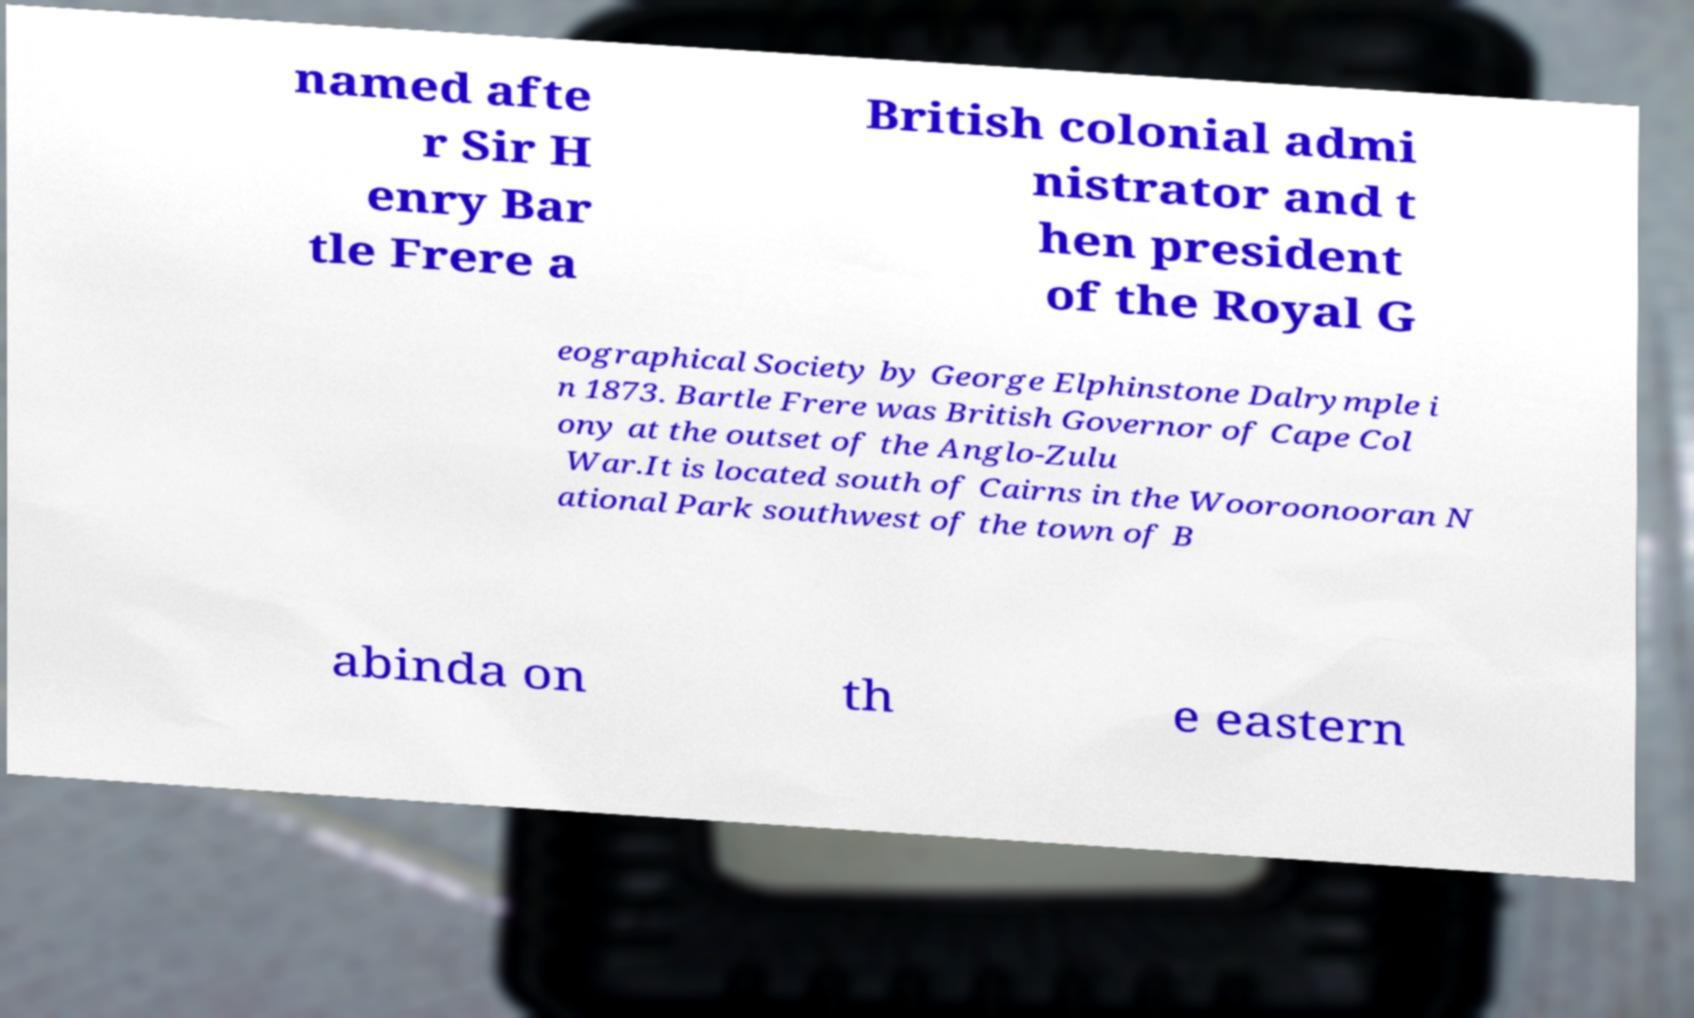Could you extract and type out the text from this image? named afte r Sir H enry Bar tle Frere a British colonial admi nistrator and t hen president of the Royal G eographical Society by George Elphinstone Dalrymple i n 1873. Bartle Frere was British Governor of Cape Col ony at the outset of the Anglo-Zulu War.It is located south of Cairns in the Wooroonooran N ational Park southwest of the town of B abinda on th e eastern 